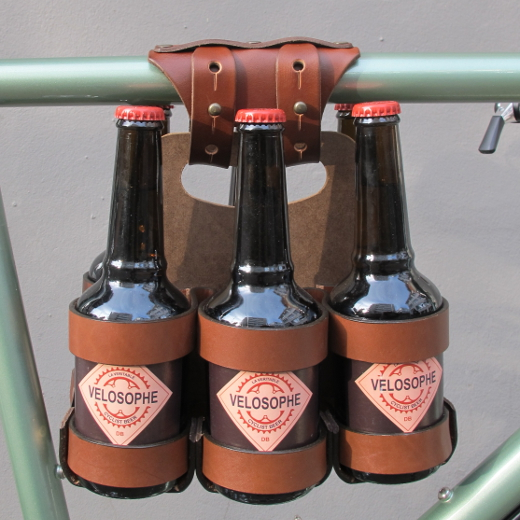Can you describe the utility and design aspects of the objects in the image? The image showcases a unique bike accessory designed for carrying three bottles securely. The holder is made from durable leather, providing a rustic and stylish appearance. The leather straps are carefully stitched and buckled to hold each bottle in place, ensuring they don't move during transport. This accessory not only serves a functional purpose but also adds an element of craftsmanship and vintage charm to the bike. How would this accessory be practical for everyday use? For daily use, this bottle holder is particularly practical for those who commute by bike and want to transport beverages safely. It keeps the bottles secure and prevents them from clinking together or falling out. Additionally, it can be easily detached and reattached, making it a versatile accessory for different biking needs. This practical solution merges functionality with style, enhancing the overall biking experience. 